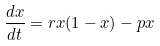<formula> <loc_0><loc_0><loc_500><loc_500>\frac { d x } { d t } = r x ( 1 - x ) - p x</formula> 